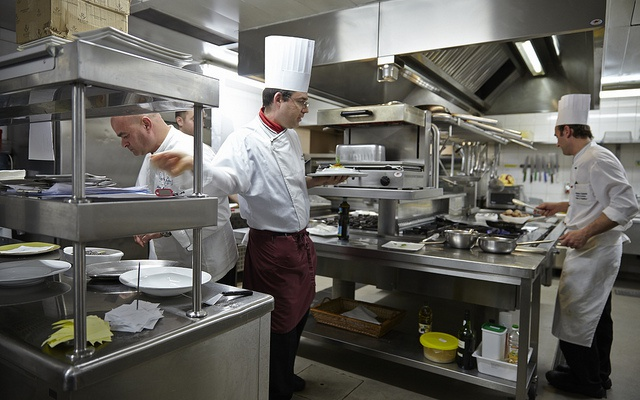Describe the objects in this image and their specific colors. I can see people in black, white, darkgray, and gray tones, people in black, gray, darkgray, and maroon tones, people in black, gray, darkgray, and white tones, refrigerator in black and gray tones, and bowl in black, lightgray, gray, and darkgray tones in this image. 